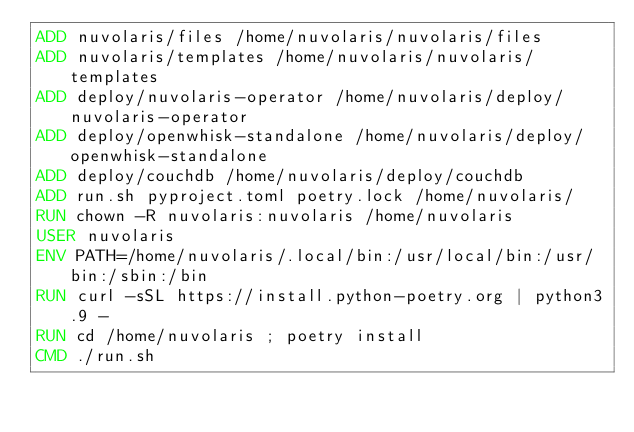<code> <loc_0><loc_0><loc_500><loc_500><_Dockerfile_>ADD nuvolaris/files /home/nuvolaris/nuvolaris/files
ADD nuvolaris/templates /home/nuvolaris/nuvolaris/templates
ADD deploy/nuvolaris-operator /home/nuvolaris/deploy/nuvolaris-operator
ADD deploy/openwhisk-standalone /home/nuvolaris/deploy/openwhisk-standalone
ADD deploy/couchdb /home/nuvolaris/deploy/couchdb
ADD run.sh pyproject.toml poetry.lock /home/nuvolaris/
RUN chown -R nuvolaris:nuvolaris /home/nuvolaris
USER nuvolaris
ENV PATH=/home/nuvolaris/.local/bin:/usr/local/bin:/usr/bin:/sbin:/bin
RUN curl -sSL https://install.python-poetry.org | python3.9 -
RUN cd /home/nuvolaris ; poetry install
CMD ./run.sh
</code> 